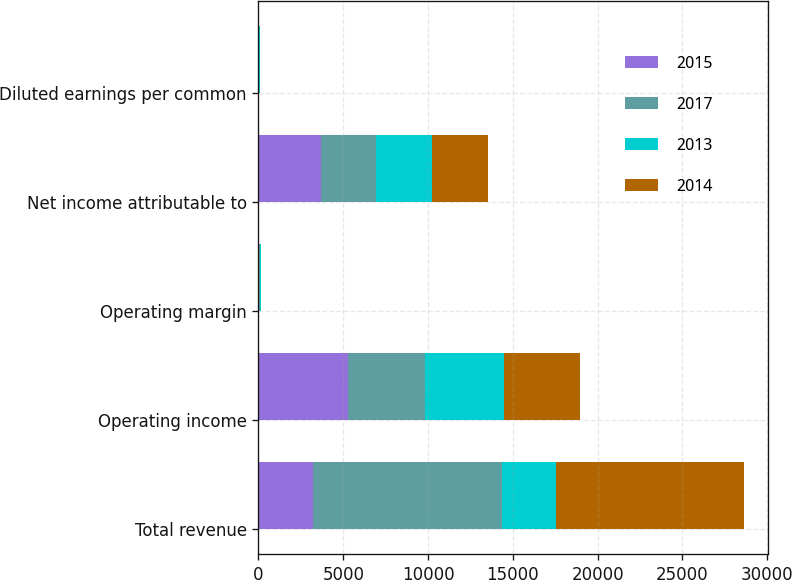Convert chart. <chart><loc_0><loc_0><loc_500><loc_500><stacked_bar_chart><ecel><fcel>Total revenue<fcel>Operating income<fcel>Operating margin<fcel>Net income attributable to<fcel>Diluted earnings per common<nl><fcel>2015<fcel>3193<fcel>5272<fcel>42.2<fcel>3716<fcel>22.6<nl><fcel>2017<fcel>11155<fcel>4570<fcel>41<fcel>3214<fcel>19.29<nl><fcel>2013<fcel>3193<fcel>4664<fcel>40.9<fcel>3313<fcel>19.6<nl><fcel>2014<fcel>11081<fcel>4474<fcel>40.4<fcel>3310<fcel>19.34<nl></chart> 